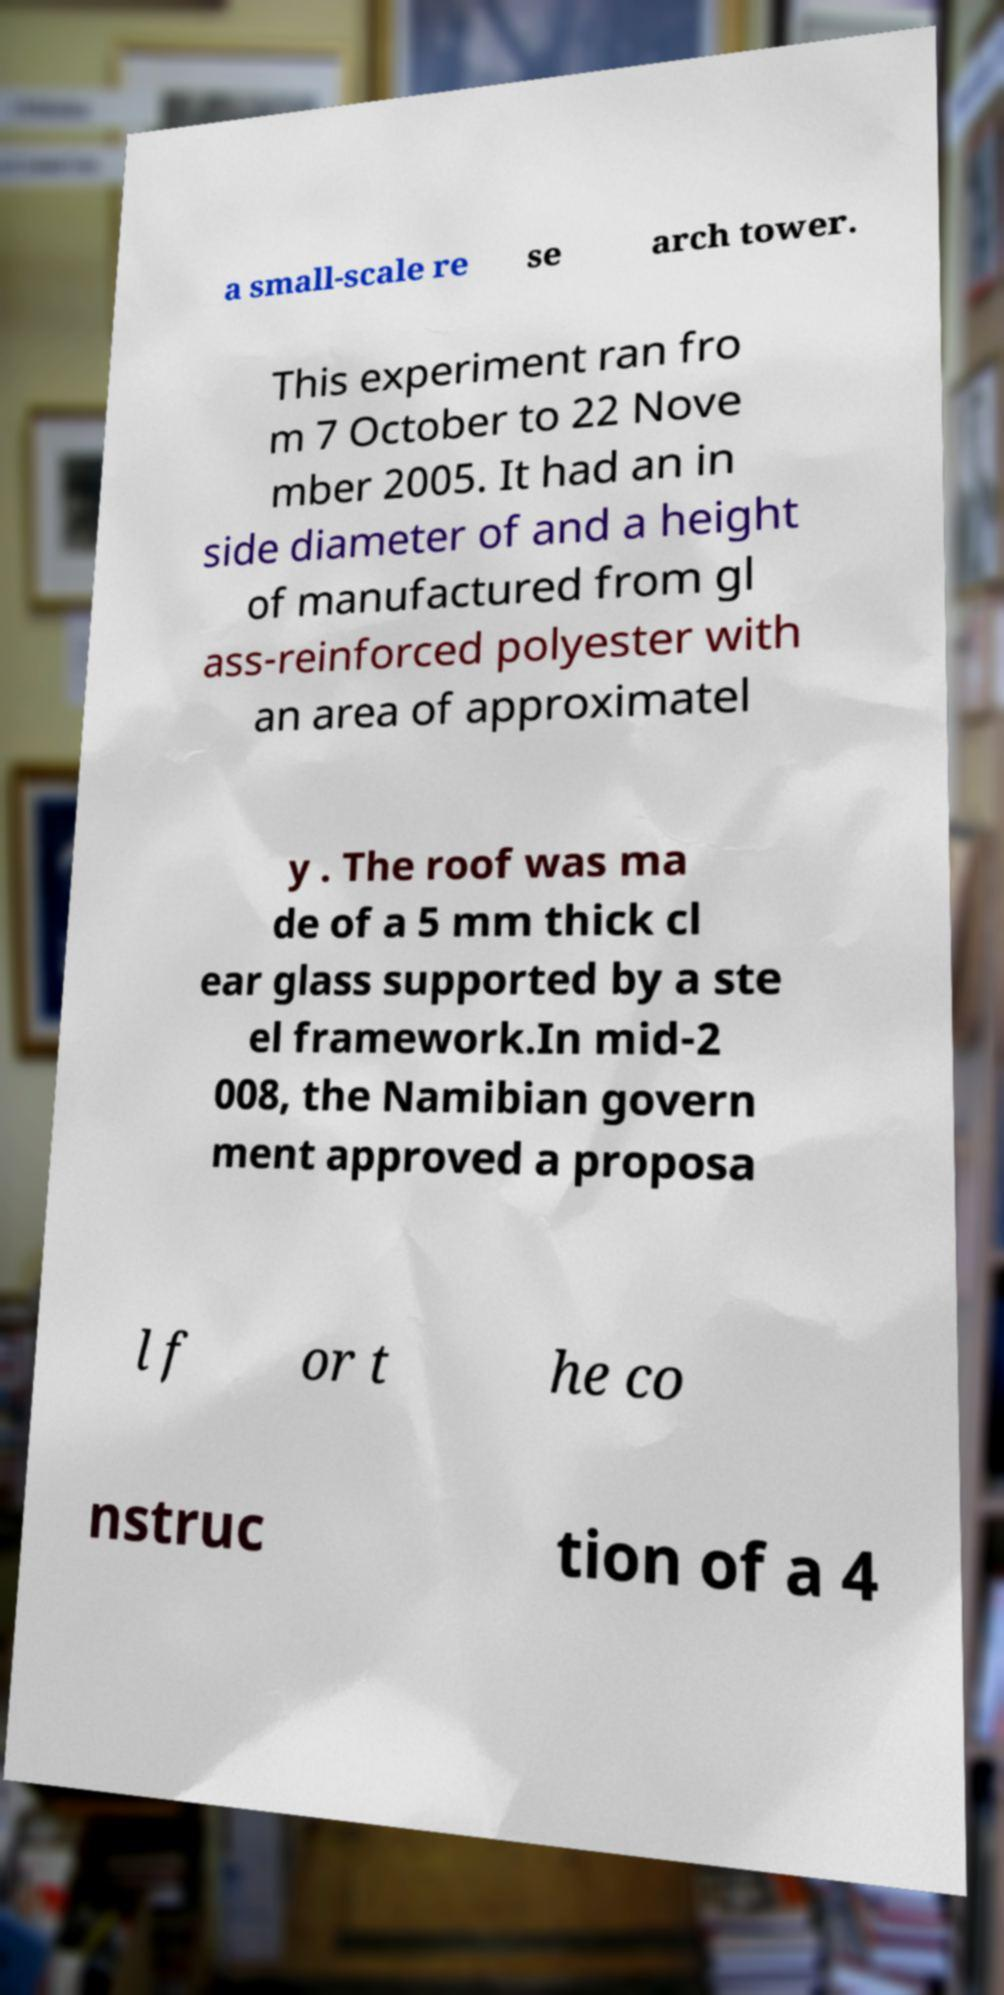Could you extract and type out the text from this image? a small-scale re se arch tower. This experiment ran fro m 7 October to 22 Nove mber 2005. It had an in side diameter of and a height of manufactured from gl ass-reinforced polyester with an area of approximatel y . The roof was ma de of a 5 mm thick cl ear glass supported by a ste el framework.In mid-2 008, the Namibian govern ment approved a proposa l f or t he co nstruc tion of a 4 